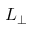Convert formula to latex. <formula><loc_0><loc_0><loc_500><loc_500>L _ { \perp }</formula> 